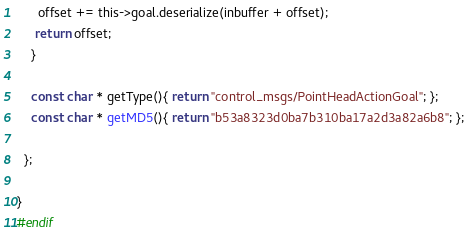Convert code to text. <code><loc_0><loc_0><loc_500><loc_500><_C_>      offset += this->goal.deserialize(inbuffer + offset);
     return offset;
    }

    const char * getType(){ return "control_msgs/PointHeadActionGoal"; };
    const char * getMD5(){ return "b53a8323d0ba7b310ba17a2d3a82a6b8"; };

  };

}
#endif
</code> 